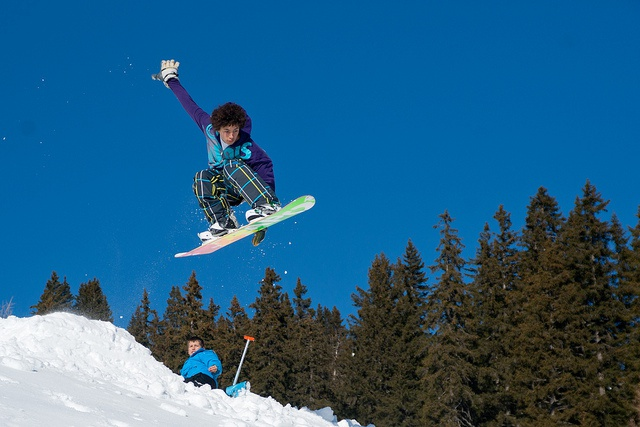Describe the objects in this image and their specific colors. I can see people in blue, navy, black, and teal tones, snowboard in blue, lightgray, lightgreen, tan, and lightpink tones, and people in blue, lightblue, black, teal, and tan tones in this image. 